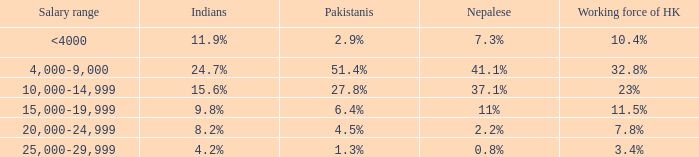If the workforce in hk accounts for 1 <4000. 